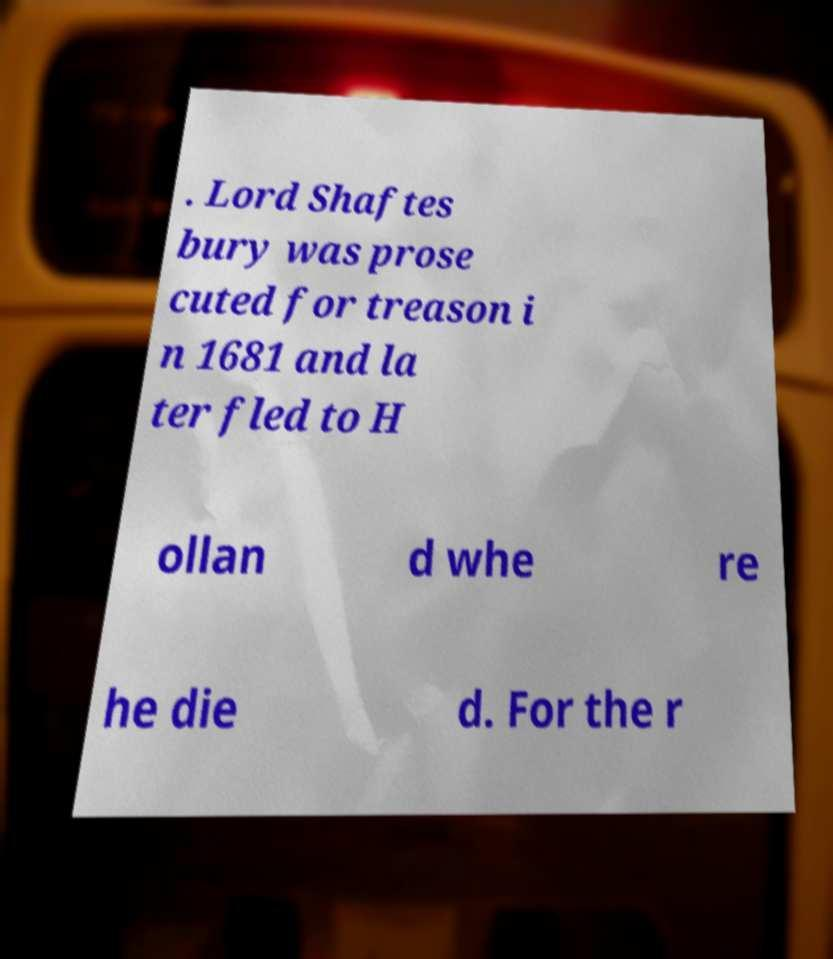What messages or text are displayed in this image? I need them in a readable, typed format. . Lord Shaftes bury was prose cuted for treason i n 1681 and la ter fled to H ollan d whe re he die d. For the r 